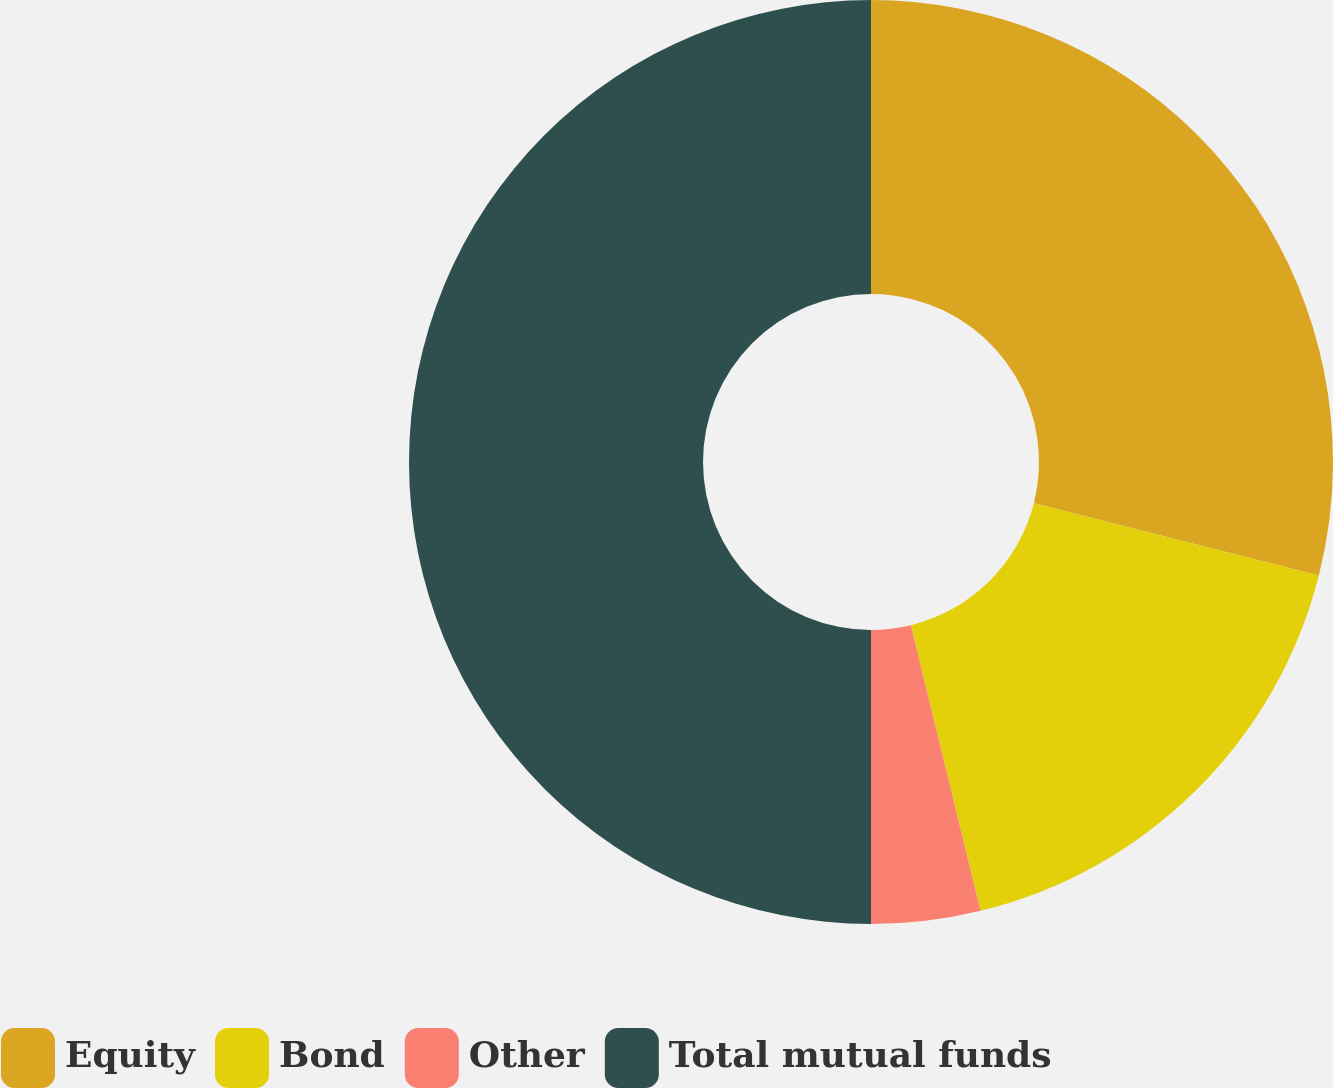Convert chart to OTSL. <chart><loc_0><loc_0><loc_500><loc_500><pie_chart><fcel>Equity<fcel>Bond<fcel>Other<fcel>Total mutual funds<nl><fcel>28.95%<fcel>17.24%<fcel>3.81%<fcel>50.0%<nl></chart> 